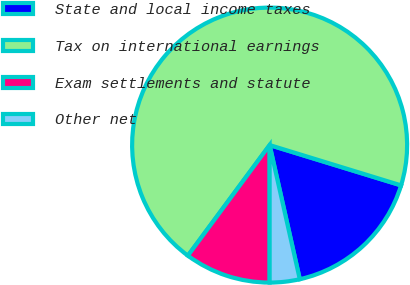<chart> <loc_0><loc_0><loc_500><loc_500><pie_chart><fcel>State and local income taxes<fcel>Tax on international earnings<fcel>Exam settlements and statute<fcel>Other net<nl><fcel>16.74%<fcel>69.6%<fcel>10.13%<fcel>3.52%<nl></chart> 